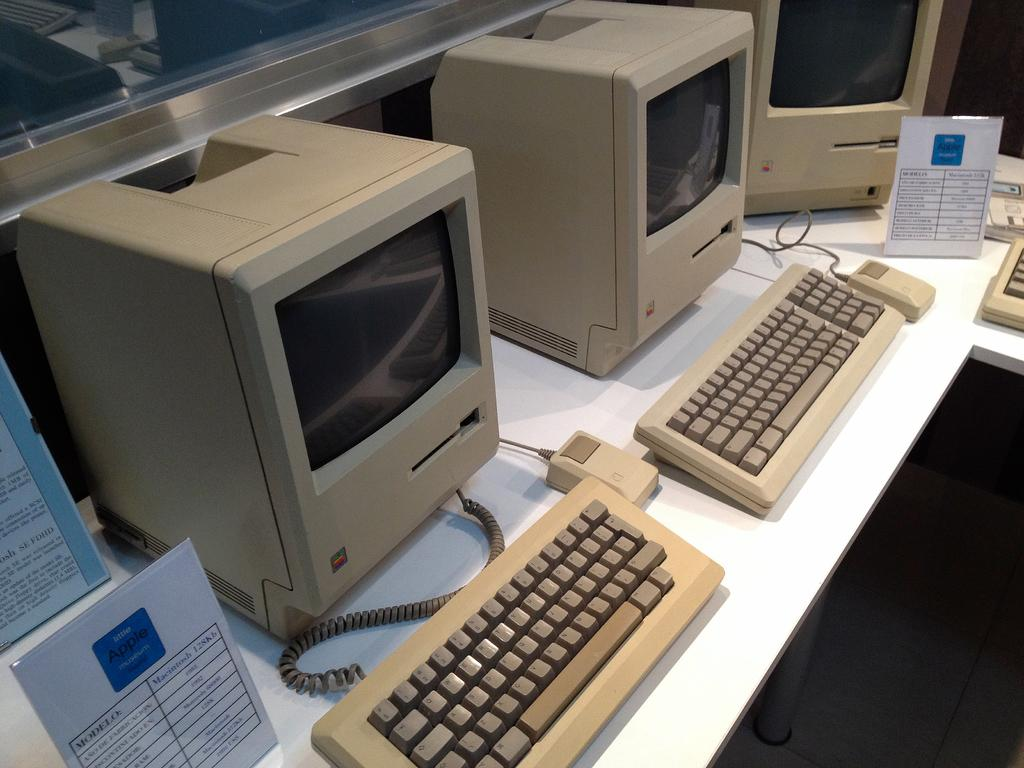<image>
Offer a succinct explanation of the picture presented. Original computers that are labeled as Apple computers 